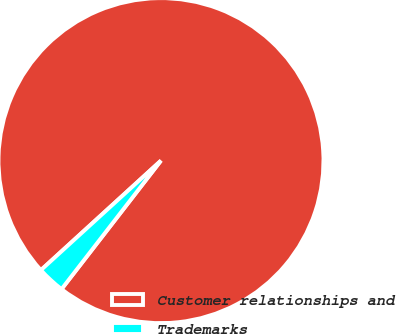<chart> <loc_0><loc_0><loc_500><loc_500><pie_chart><fcel>Customer relationships and<fcel>Trademarks<nl><fcel>97.25%<fcel>2.75%<nl></chart> 